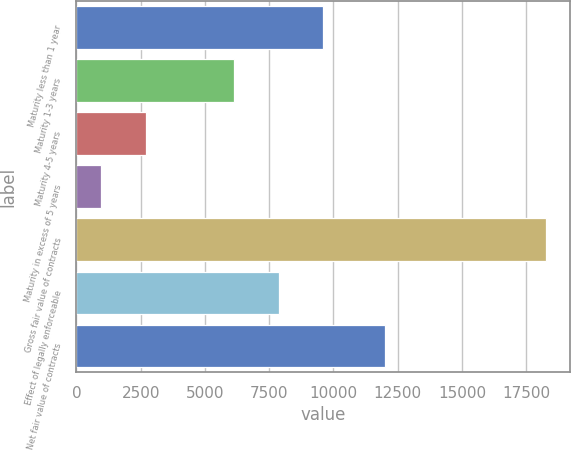<chart> <loc_0><loc_0><loc_500><loc_500><bar_chart><fcel>Maturity less than 1 year<fcel>Maturity 1-3 years<fcel>Maturity 4-5 years<fcel>Maturity in excess of 5 years<fcel>Gross fair value of contracts<fcel>Effect of legally enforceable<fcel>Net fair value of contracts<nl><fcel>9612.2<fcel>6148<fcel>2692.1<fcel>960<fcel>18281<fcel>7880.1<fcel>12025<nl></chart> 